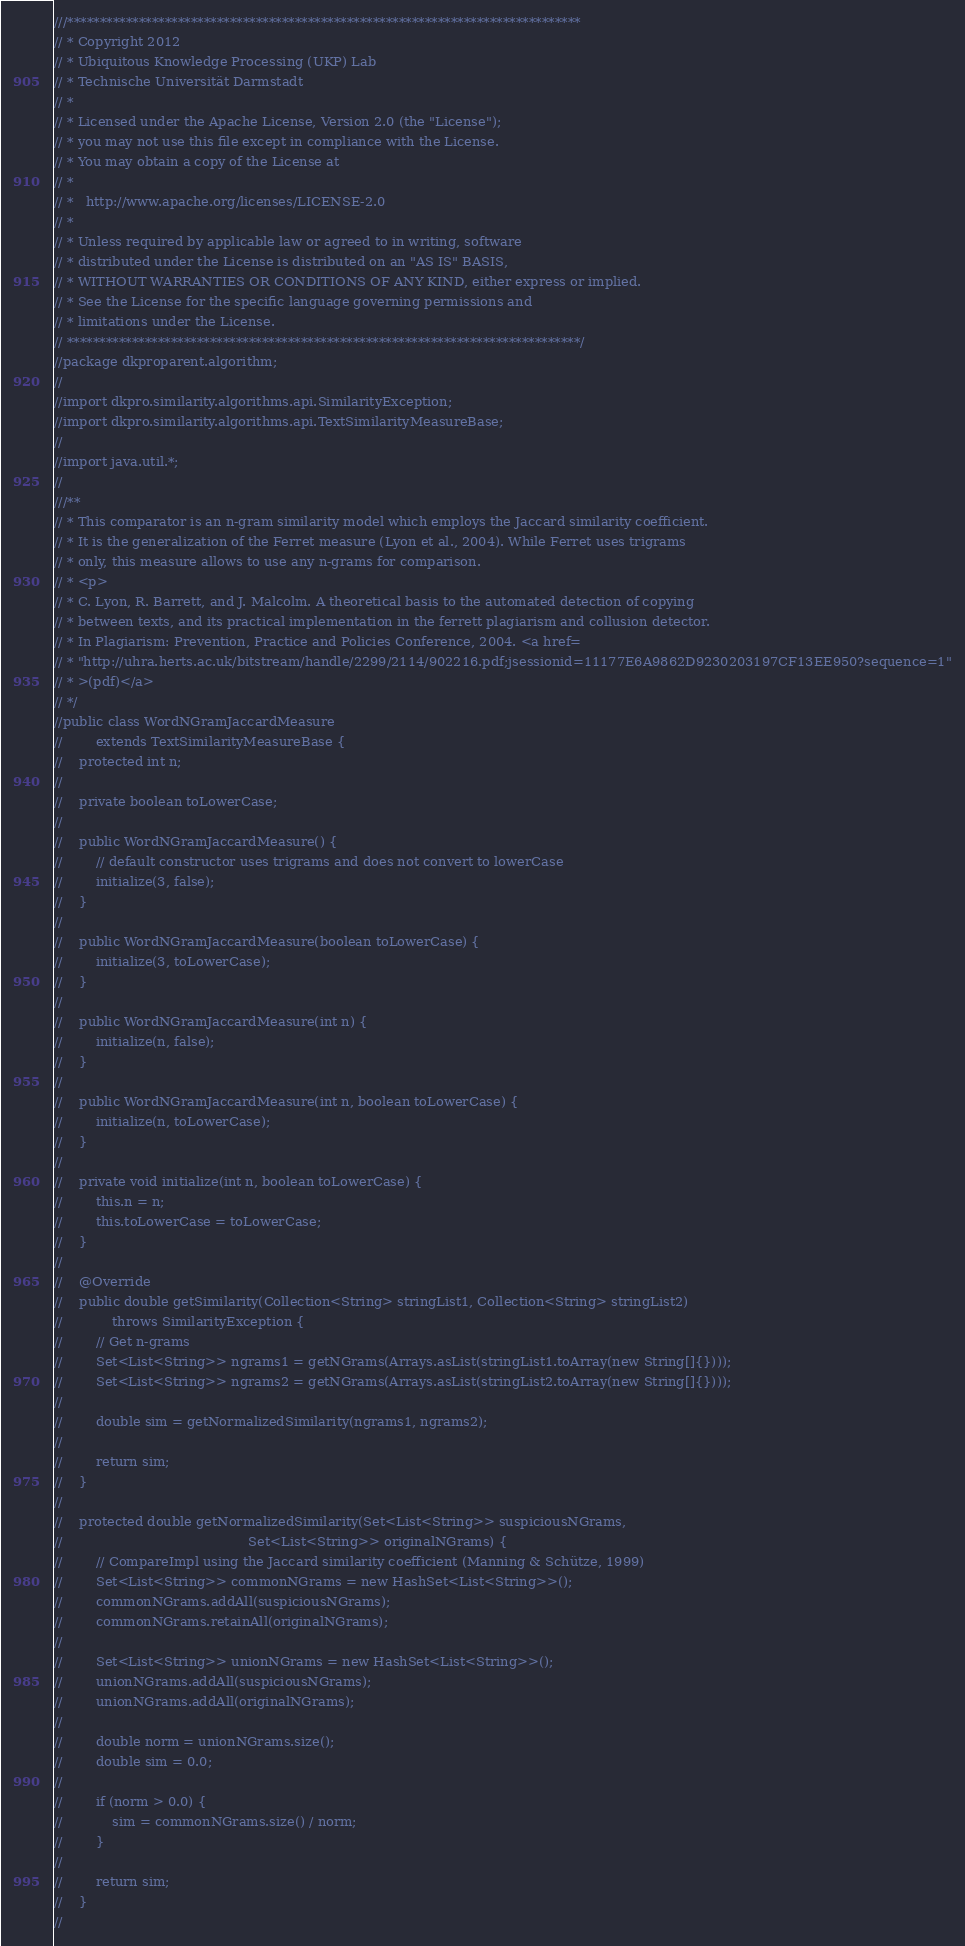<code> <loc_0><loc_0><loc_500><loc_500><_Java_>///*******************************************************************************
// * Copyright 2012
// * Ubiquitous Knowledge Processing (UKP) Lab
// * Technische Universität Darmstadt
// *
// * Licensed under the Apache License, Version 2.0 (the "License");
// * you may not use this file except in compliance with the License.
// * You may obtain a copy of the License at
// *
// *   http://www.apache.org/licenses/LICENSE-2.0
// *
// * Unless required by applicable law or agreed to in writing, software
// * distributed under the License is distributed on an "AS IS" BASIS,
// * WITHOUT WARRANTIES OR CONDITIONS OF ANY KIND, either express or implied.
// * See the License for the specific language governing permissions and
// * limitations under the License.
// *******************************************************************************/
//package dkproparent.algorithm;
//
//import dkpro.similarity.algorithms.api.SimilarityException;
//import dkpro.similarity.algorithms.api.TextSimilarityMeasureBase;
//
//import java.util.*;
//
///**
// * This comparator is an n-gram similarity model which employs the Jaccard similarity coefficient.
// * It is the generalization of the Ferret measure (Lyon et al., 2004). While Ferret uses trigrams
// * only, this measure allows to use any n-grams for comparison.
// * <p>
// * C. Lyon, R. Barrett, and J. Malcolm. A theoretical basis to the automated detection of copying
// * between texts, and its practical implementation in the ferrett plagiarism and collusion detector.
// * In Plagiarism: Prevention, Practice and Policies Conference, 2004. <a href=
// * "http://uhra.herts.ac.uk/bitstream/handle/2299/2114/902216.pdf;jsessionid=11177E6A9862D9230203197CF13EE950?sequence=1"
// * >(pdf)</a>
// */
//public class WordNGramJaccardMeasure
//        extends TextSimilarityMeasureBase {
//    protected int n;
//
//    private boolean toLowerCase;
//
//    public WordNGramJaccardMeasure() {
//        // default constructor uses trigrams and does not convert to lowerCase
//        initialize(3, false);
//    }
//
//    public WordNGramJaccardMeasure(boolean toLowerCase) {
//        initialize(3, toLowerCase);
//    }
//
//    public WordNGramJaccardMeasure(int n) {
//        initialize(n, false);
//    }
//
//    public WordNGramJaccardMeasure(int n, boolean toLowerCase) {
//        initialize(n, toLowerCase);
//    }
//
//    private void initialize(int n, boolean toLowerCase) {
//        this.n = n;
//        this.toLowerCase = toLowerCase;
//    }
//
//    @Override
//    public double getSimilarity(Collection<String> stringList1, Collection<String> stringList2)
//            throws SimilarityException {
//        // Get n-grams
//        Set<List<String>> ngrams1 = getNGrams(Arrays.asList(stringList1.toArray(new String[]{})));
//        Set<List<String>> ngrams2 = getNGrams(Arrays.asList(stringList2.toArray(new String[]{})));
//
//        double sim = getNormalizedSimilarity(ngrams1, ngrams2);
//
//        return sim;
//    }
//
//    protected double getNormalizedSimilarity(Set<List<String>> suspiciousNGrams,
//                                             Set<List<String>> originalNGrams) {
//        // CompareImpl using the Jaccard similarity coefficient (Manning & Schütze, 1999)
//        Set<List<String>> commonNGrams = new HashSet<List<String>>();
//        commonNGrams.addAll(suspiciousNGrams);
//        commonNGrams.retainAll(originalNGrams);
//
//        Set<List<String>> unionNGrams = new HashSet<List<String>>();
//        unionNGrams.addAll(suspiciousNGrams);
//        unionNGrams.addAll(originalNGrams);
//
//        double norm = unionNGrams.size();
//        double sim = 0.0;
//
//        if (norm > 0.0) {
//            sim = commonNGrams.size() / norm;
//        }
//
//        return sim;
//    }
//</code> 